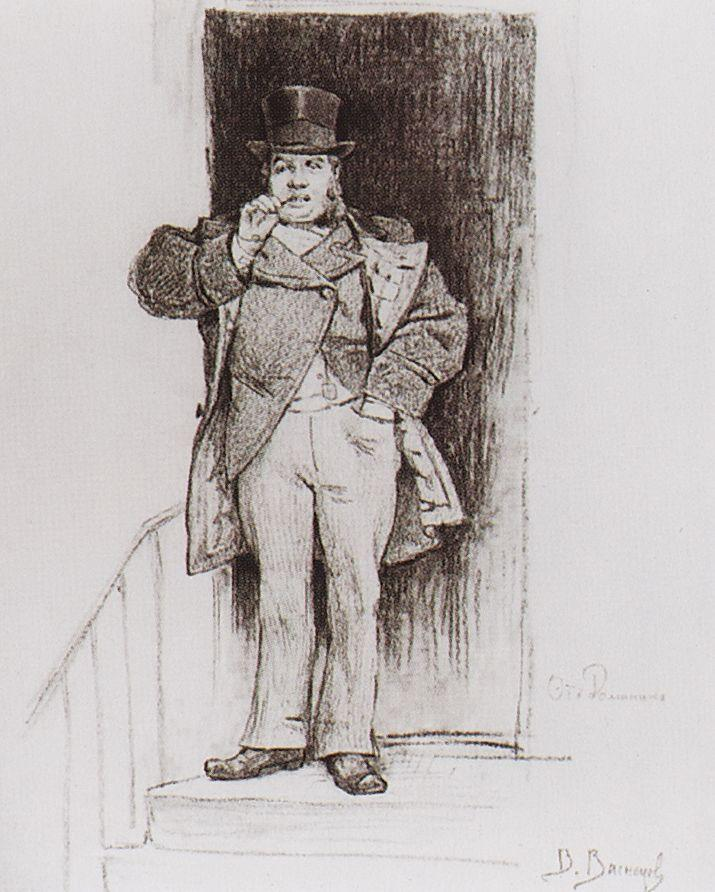Can you describe the significance of the man's expression in this artwork? The man's slight smile and poised demeanor suggest a sense of contentment and confidence. His expression might be intended to convey a certain approachability and charm, characteristics valued in a gentleman of his era. This subtle smile, combined with his direct gaze, might suggest that he is a welcoming yet respected figure in his community. 